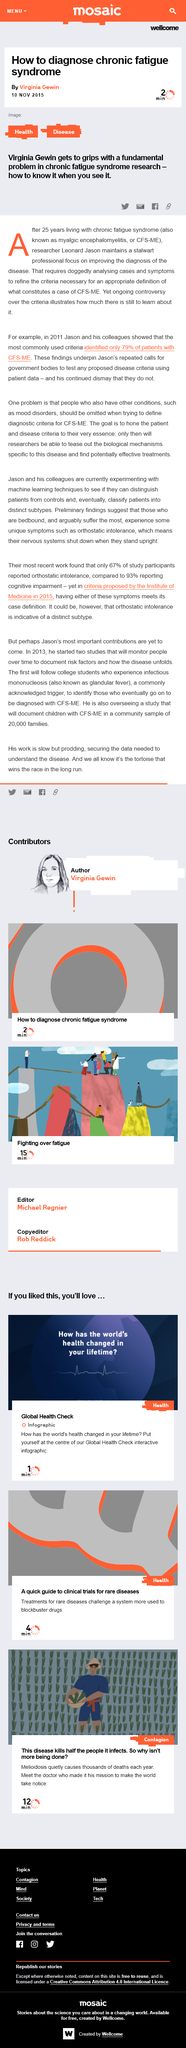Draw attention to some important aspects in this diagram. Leonard Jason is a researcher who is working on improving the diagnosis of Chronic Fatigue Syndrome. This article discusses Chronic Fatigue Syndrome. The article was written by Virginia Gewin. 